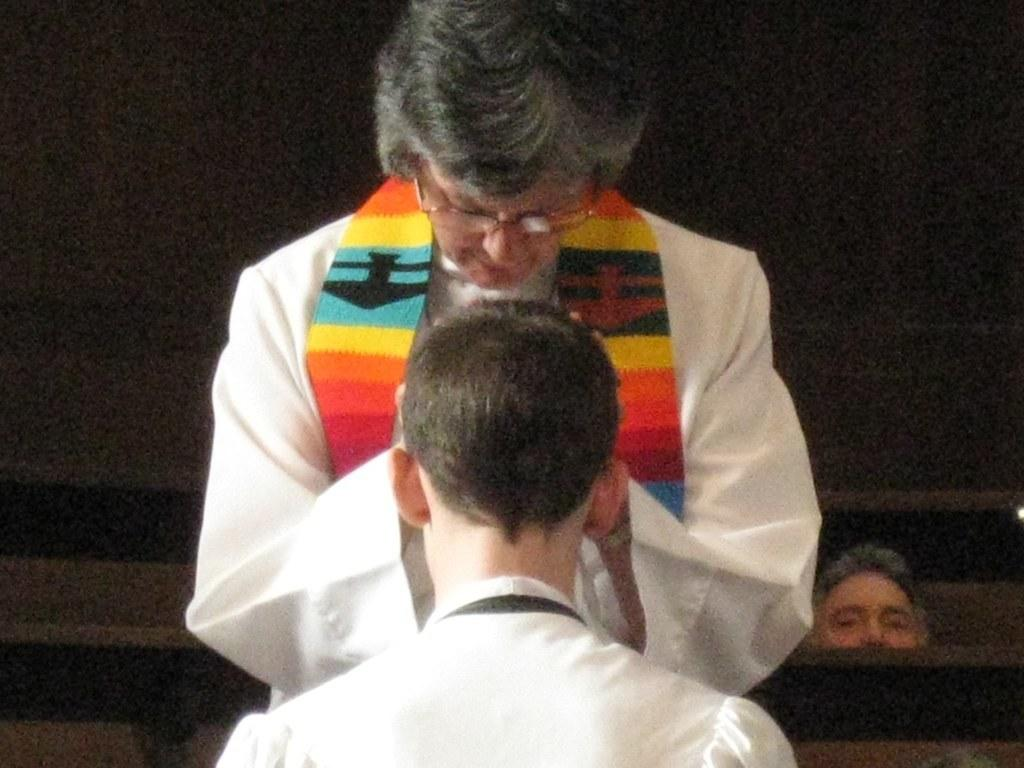How many individuals are present in the image? There are three people in the image. What is the main object that the people are interacting with in the image? There is a bench in the image. What type of soap is being used by the people in the image? There is no soap present in the image; it features three people and a bench. What act are the people performing in the image? The image does not depict a specific act or performance; it simply shows three people and a bench. 